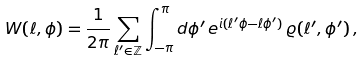<formula> <loc_0><loc_0><loc_500><loc_500>W ( \ell , \phi ) = \frac { 1 } { 2 \pi } \sum _ { \ell ^ { \prime } \in \mathbb { Z } } \int _ { - \pi } ^ { \pi } d \phi ^ { \prime } \, e ^ { i ( \ell ^ { \prime } \phi - \ell \phi ^ { \prime } ) } \, \varrho ( \ell ^ { \prime } , \phi ^ { \prime } ) \, ,</formula> 